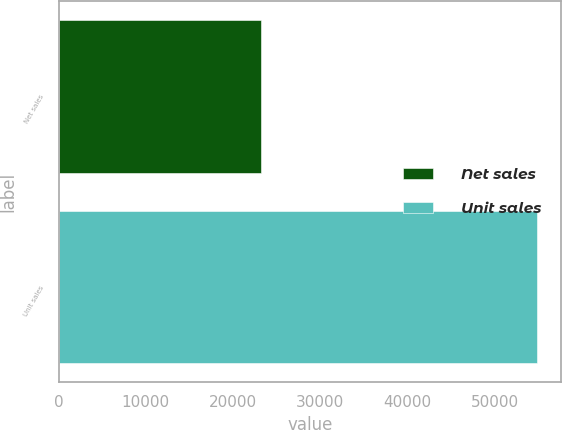Convert chart. <chart><loc_0><loc_0><loc_500><loc_500><bar_chart><fcel>Net sales<fcel>Unit sales<nl><fcel>23227<fcel>54856<nl></chart> 